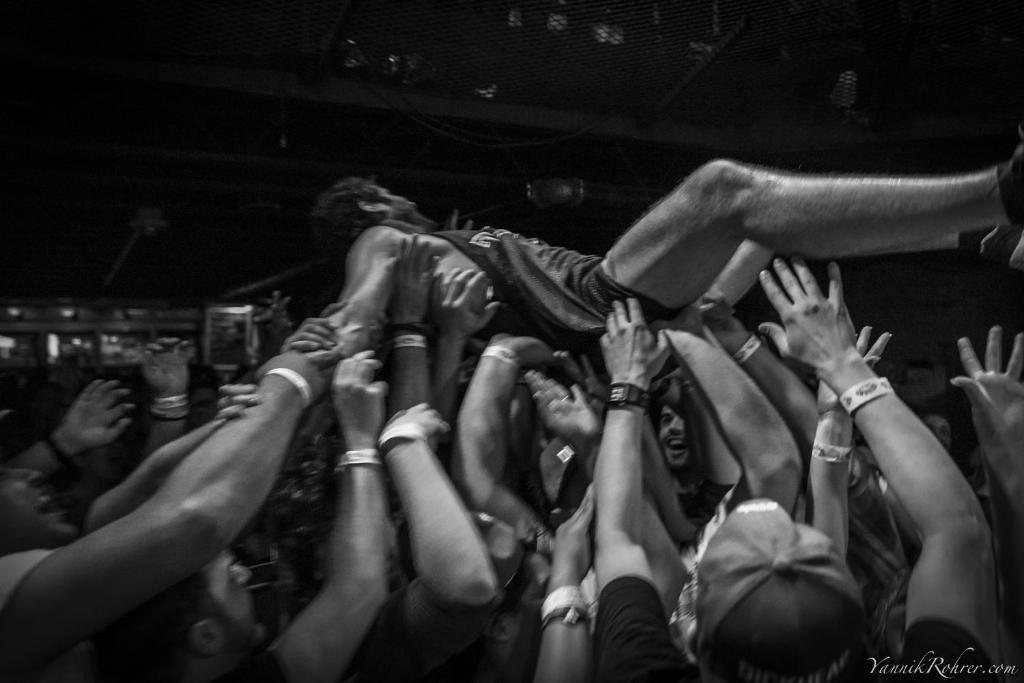What is the color scheme of the image? The image is black and white. What is happening in the image involving a group of people? The group of people is lifting a man on their hands. What can be seen in the background of the image? There are grills and electric lights in the background of the image. Where is the sofa located in the image? There is no sofa present in the image. What type of property is being sold in the image? There is no property being sold in the image; it features a group of people lifting a man. 